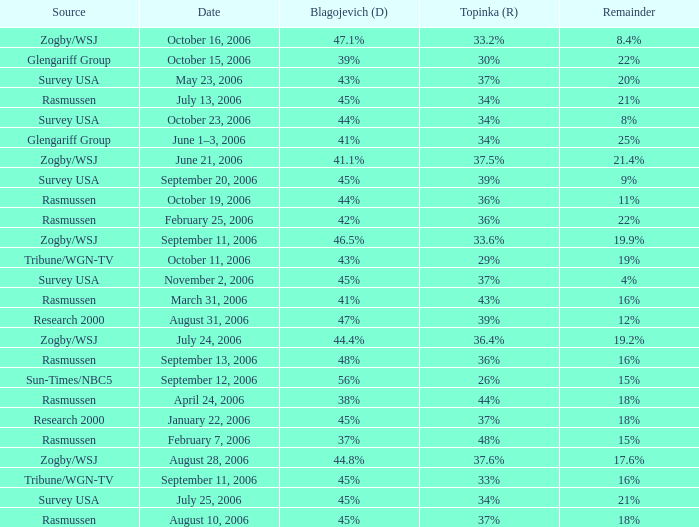Which Date has a Remainder of 20%? May 23, 2006. 